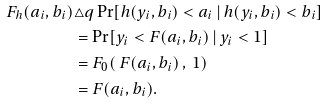<formula> <loc_0><loc_0><loc_500><loc_500>F _ { h } ( a _ { i } , b _ { i } ) & \triangle q \Pr [ h ( y _ { i } , b _ { i } ) < a _ { i } \, | \, h ( y _ { i } , b _ { i } ) < b _ { i } ] \\ & = \Pr [ y _ { i } < F ( a _ { i } , b _ { i } ) \, | \, y _ { i } < 1 ] \\ & = F _ { 0 } ( \, F ( a _ { i } , b _ { i } ) \, , \, 1 ) \\ & = F ( a _ { i } , b _ { i } ) .</formula> 